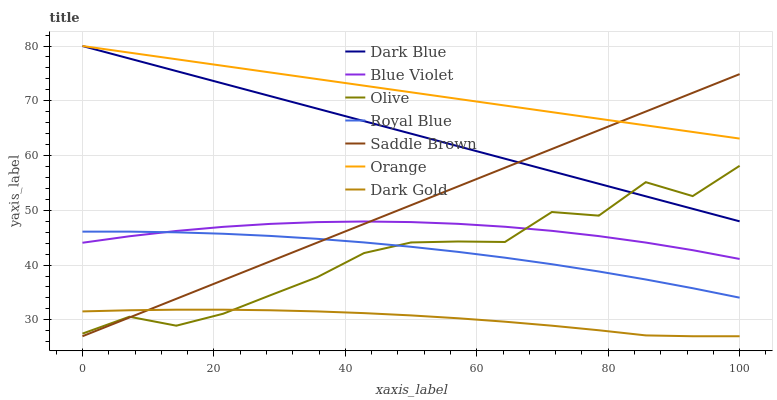Does Dark Gold have the minimum area under the curve?
Answer yes or no. Yes. Does Orange have the maximum area under the curve?
Answer yes or no. Yes. Does Dark Blue have the minimum area under the curve?
Answer yes or no. No. Does Dark Blue have the maximum area under the curve?
Answer yes or no. No. Is Saddle Brown the smoothest?
Answer yes or no. Yes. Is Olive the roughest?
Answer yes or no. Yes. Is Dark Gold the smoothest?
Answer yes or no. No. Is Dark Gold the roughest?
Answer yes or no. No. Does Dark Blue have the lowest value?
Answer yes or no. No. Does Dark Gold have the highest value?
Answer yes or no. No. Is Blue Violet less than Orange?
Answer yes or no. Yes. Is Orange greater than Royal Blue?
Answer yes or no. Yes. Does Blue Violet intersect Orange?
Answer yes or no. No. 